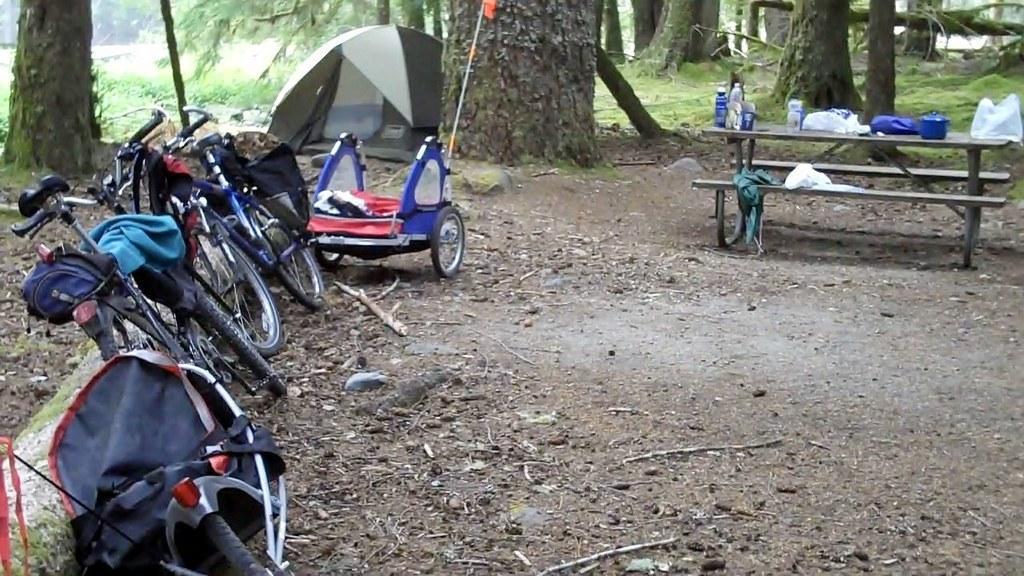Can you describe this image briefly? This image looks like it is clicked in a garden. To the right, there is a bench, on which bottles boxes and some plastic bags are kept. To the left, there are two bicycles and a trolley. In the middle, there is a tent beside the tree. In the background, there are many trees with grass. 